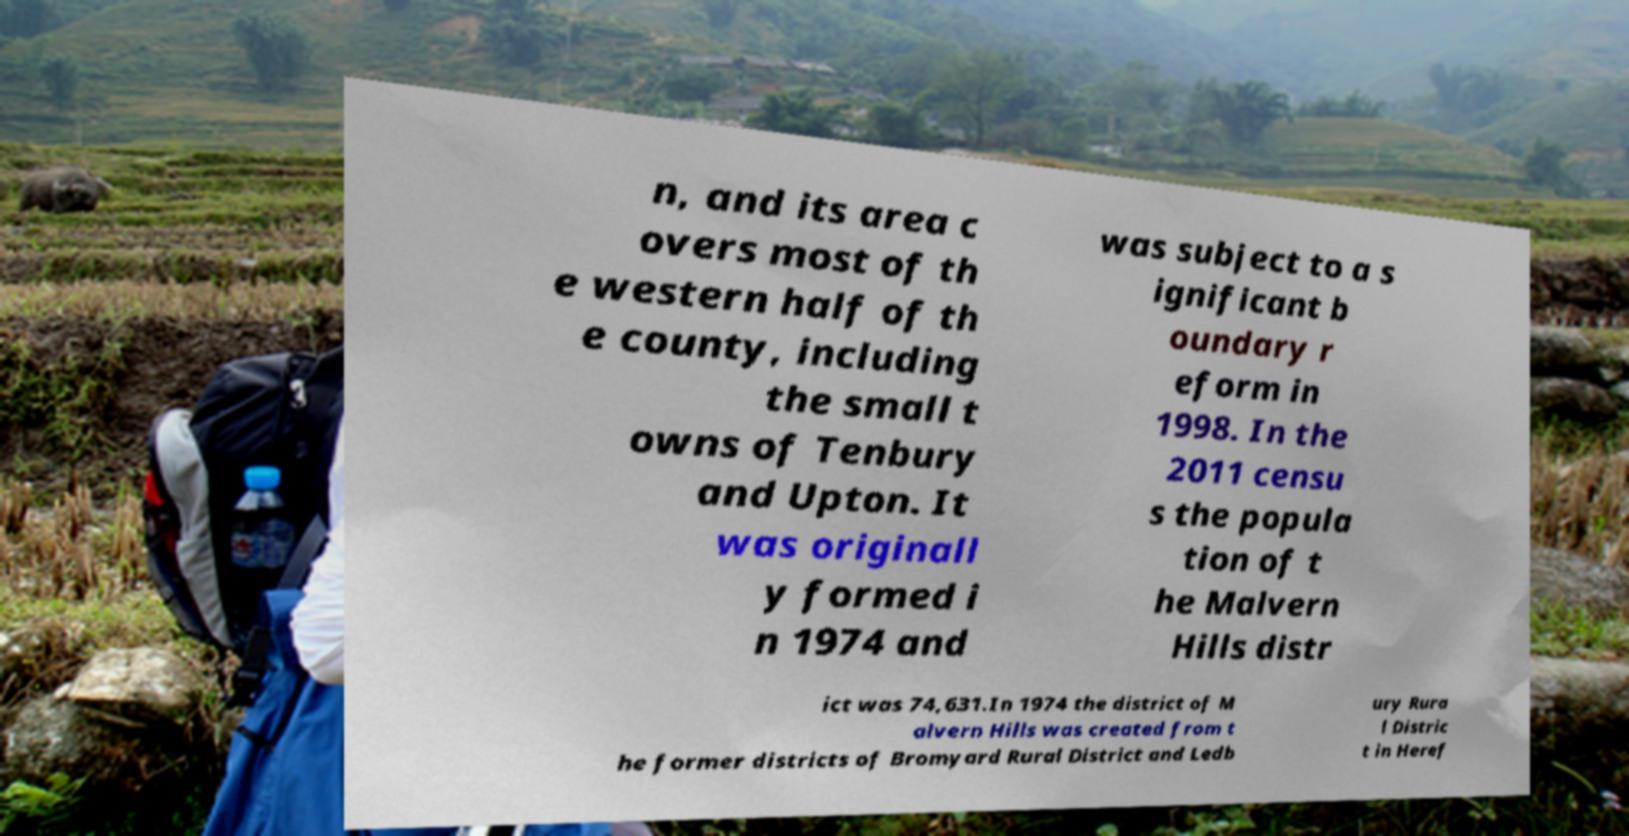For documentation purposes, I need the text within this image transcribed. Could you provide that? n, and its area c overs most of th e western half of th e county, including the small t owns of Tenbury and Upton. It was originall y formed i n 1974 and was subject to a s ignificant b oundary r eform in 1998. In the 2011 censu s the popula tion of t he Malvern Hills distr ict was 74,631.In 1974 the district of M alvern Hills was created from t he former districts of Bromyard Rural District and Ledb ury Rura l Distric t in Heref 